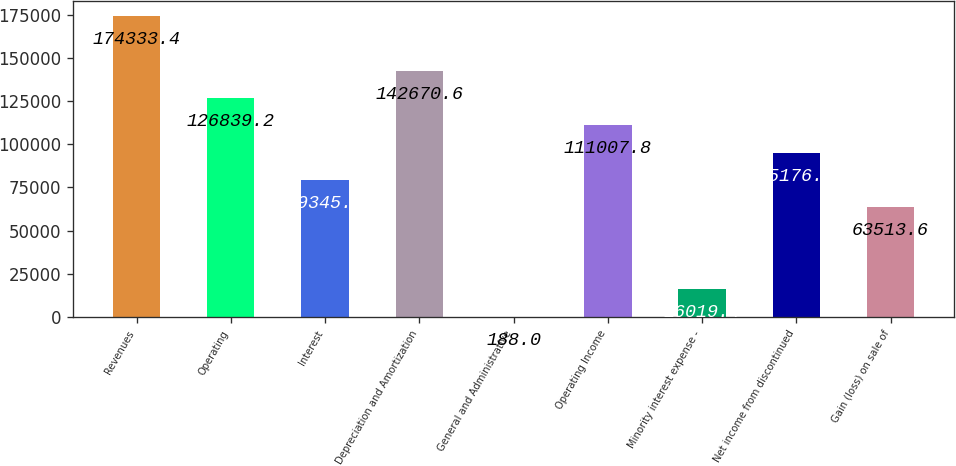Convert chart to OTSL. <chart><loc_0><loc_0><loc_500><loc_500><bar_chart><fcel>Revenues<fcel>Operating<fcel>Interest<fcel>Depreciation and Amortization<fcel>General and Administrative<fcel>Operating Income<fcel>Minority interest expense -<fcel>Net income from discontinued<fcel>Gain (loss) on sale of<nl><fcel>174333<fcel>126839<fcel>79345<fcel>142671<fcel>188<fcel>111008<fcel>16019.4<fcel>95176.4<fcel>63513.6<nl></chart> 